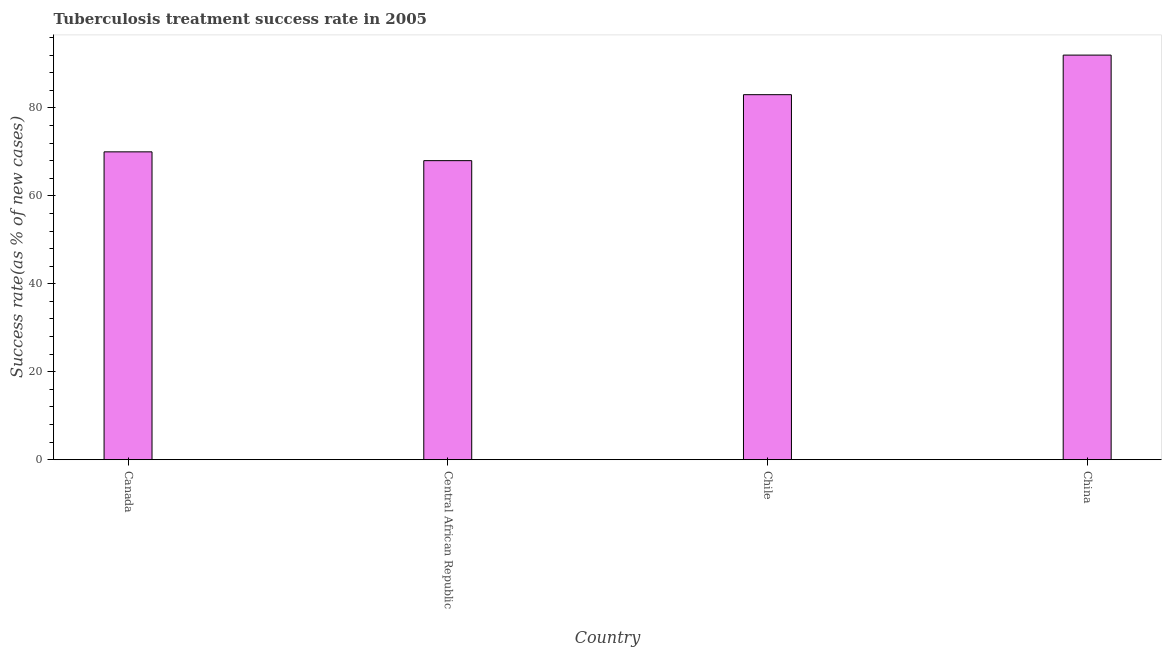Does the graph contain any zero values?
Make the answer very short. No. What is the title of the graph?
Provide a short and direct response. Tuberculosis treatment success rate in 2005. What is the label or title of the Y-axis?
Offer a very short reply. Success rate(as % of new cases). Across all countries, what is the maximum tuberculosis treatment success rate?
Give a very brief answer. 92. In which country was the tuberculosis treatment success rate minimum?
Give a very brief answer. Central African Republic. What is the sum of the tuberculosis treatment success rate?
Your answer should be very brief. 313. What is the average tuberculosis treatment success rate per country?
Offer a terse response. 78. What is the median tuberculosis treatment success rate?
Your answer should be compact. 76.5. What is the ratio of the tuberculosis treatment success rate in Canada to that in Chile?
Your response must be concise. 0.84. Is the difference between the tuberculosis treatment success rate in Canada and China greater than the difference between any two countries?
Give a very brief answer. No. What is the difference between the highest and the lowest tuberculosis treatment success rate?
Make the answer very short. 24. How many bars are there?
Offer a terse response. 4. What is the Success rate(as % of new cases) in Central African Republic?
Your response must be concise. 68. What is the Success rate(as % of new cases) in China?
Provide a short and direct response. 92. What is the difference between the Success rate(as % of new cases) in Canada and Central African Republic?
Your answer should be compact. 2. What is the difference between the Success rate(as % of new cases) in Central African Republic and Chile?
Offer a very short reply. -15. What is the ratio of the Success rate(as % of new cases) in Canada to that in Central African Republic?
Your answer should be very brief. 1.03. What is the ratio of the Success rate(as % of new cases) in Canada to that in Chile?
Make the answer very short. 0.84. What is the ratio of the Success rate(as % of new cases) in Canada to that in China?
Give a very brief answer. 0.76. What is the ratio of the Success rate(as % of new cases) in Central African Republic to that in Chile?
Offer a terse response. 0.82. What is the ratio of the Success rate(as % of new cases) in Central African Republic to that in China?
Keep it short and to the point. 0.74. What is the ratio of the Success rate(as % of new cases) in Chile to that in China?
Offer a terse response. 0.9. 